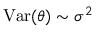Convert formula to latex. <formula><loc_0><loc_0><loc_500><loc_500>V a r ( \theta ) \sim \sigma ^ { 2 }</formula> 